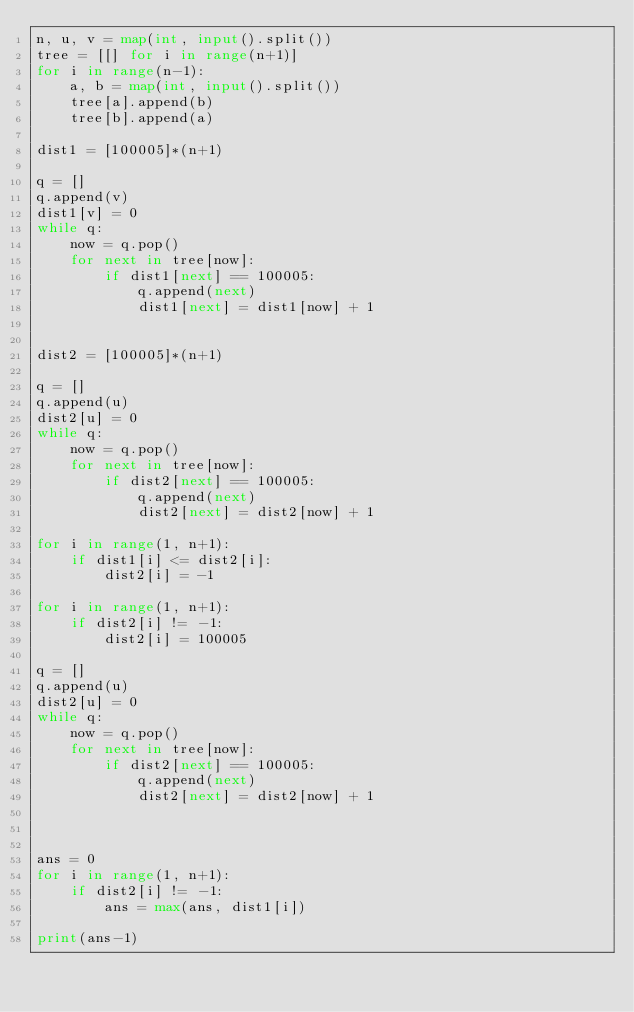<code> <loc_0><loc_0><loc_500><loc_500><_Python_>n, u, v = map(int, input().split())
tree = [[] for i in range(n+1)]
for i in range(n-1):
    a, b = map(int, input().split())
    tree[a].append(b)
    tree[b].append(a)

dist1 = [100005]*(n+1)

q = []
q.append(v)
dist1[v] = 0
while q:
    now = q.pop()
    for next in tree[now]:
        if dist1[next] == 100005:
            q.append(next)
            dist1[next] = dist1[now] + 1


dist2 = [100005]*(n+1)

q = []
q.append(u)
dist2[u] = 0
while q:
    now = q.pop()
    for next in tree[now]:
        if dist2[next] == 100005:
            q.append(next)
            dist2[next] = dist2[now] + 1

for i in range(1, n+1):
    if dist1[i] <= dist2[i]:
        dist2[i] = -1

for i in range(1, n+1):
    if dist2[i] != -1:
        dist2[i] = 100005

q = []
q.append(u)
dist2[u] = 0
while q:
    now = q.pop()
    for next in tree[now]:
        if dist2[next] == 100005:
            q.append(next)
            dist2[next] = dist2[now] + 1



ans = 0
for i in range(1, n+1):
    if dist2[i] != -1:
        ans = max(ans, dist1[i])

print(ans-1)
</code> 